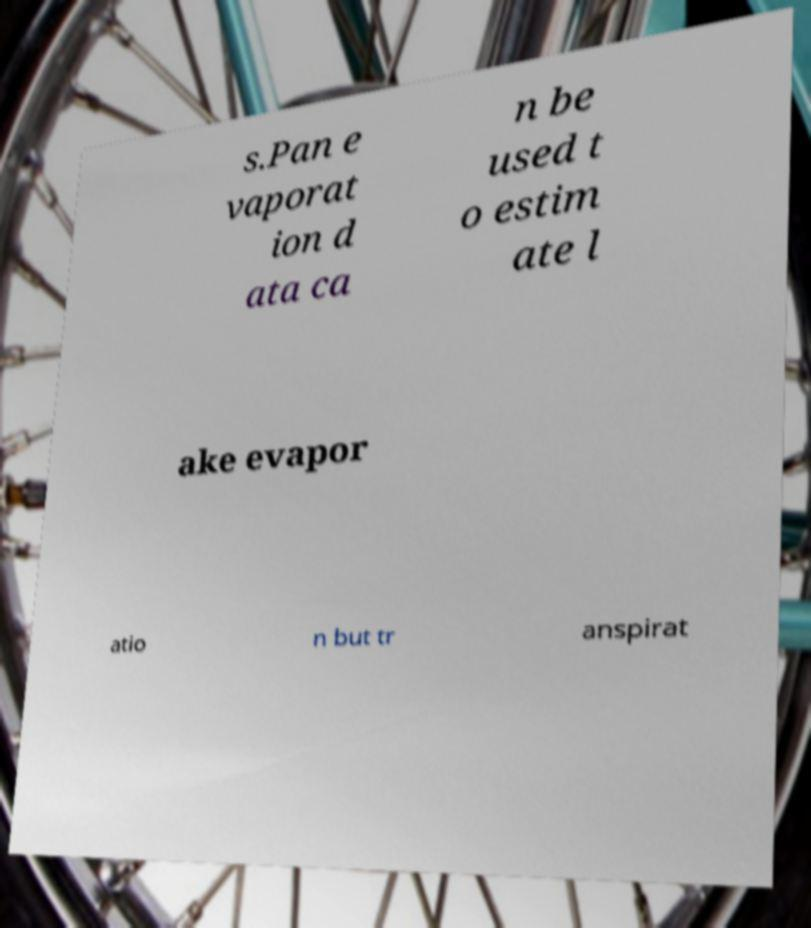What messages or text are displayed in this image? I need them in a readable, typed format. s.Pan e vaporat ion d ata ca n be used t o estim ate l ake evapor atio n but tr anspirat 